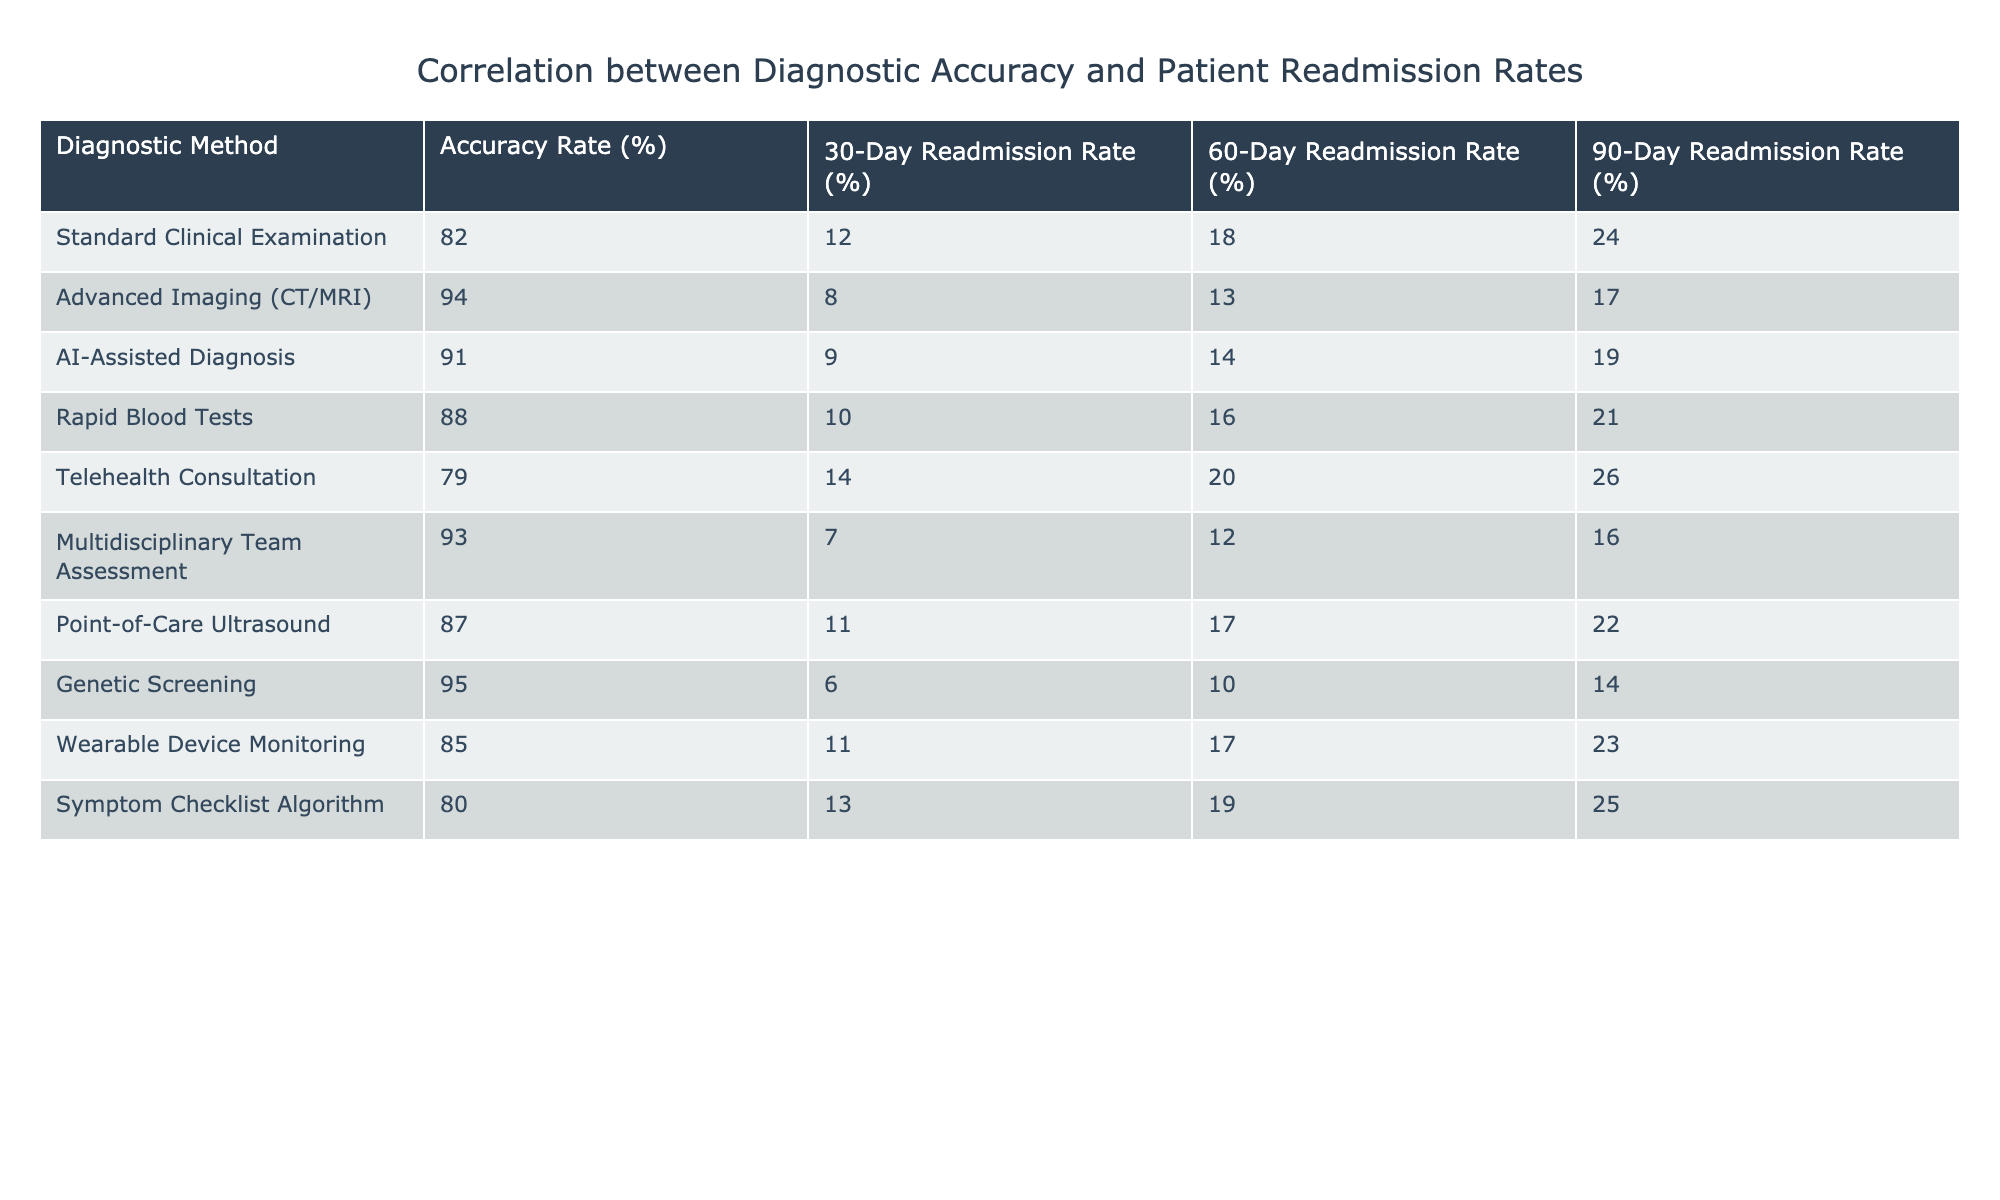What is the accuracy rate of Advanced Imaging? The accuracy rate for Advanced Imaging is listed in the table under the "Accuracy Rate (%)" column. It shows 94%.
Answer: 94% Which diagnostic method has the lowest 30-day readmission rate? By looking at the "30-Day Readmission Rate (%)" column, the lowest value is 6%, which corresponds to Genetic Screening.
Answer: Genetic Screening What is the difference in accuracy rate between Standard Clinical Examination and Telehealth Consultation? The accuracy rate for Standard Clinical Examination is 82% and for Telehealth Consultation, it is 79%. The difference is 82% - 79% = 3%.
Answer: 3% If a hospital uses the Multidisciplinary Team Assessment, what would be the expected 60-day readmission rate? The expected 60-day readmission rate for Multidisciplinary Team Assessment can be found in the "60-Day Readmission Rate (%)" column, which is 12%.
Answer: 12% True or False: AI-Assisted Diagnosis has a higher 90-day readmission rate than Rapid Blood Tests. From the table, the 90-day readmission rate for AI-Assisted Diagnosis is 19% and for Rapid Blood Tests, it is 21%. Therefore, AI-Assisted Diagnosis has a lower 90-day readmission rate.
Answer: False What is the average of the 30-day readmission rates for all diagnostic methods? First, sum all the values in the "30-Day Readmission Rate (%)" column: 12 + 8 + 9 + 10 + 14 + 7 + 11 + 6 + 11 + 13 = 91. There are 10 methods, so the average is 91 / 10 = 9.1%.
Answer: 9.1% Which diagnostic method offers both the highest accuracy rate and the lowest readmission rates across all time periods? By checking both accuracy and readmission rates, Genetic Screening has the highest accuracy at 95% and the lowest readmission rates at 6%, 10%, and 14% for the respective periods.
Answer: Genetic Screening What is the combined readmission rate for the 30-day and 60-day periods for Point-of-Care Ultrasound? The 30-day readmission rate for Point-of-Care Ultrasound is 11% and the 60-day rate is 17%. Summing these gives 11% + 17% = 28%.
Answer: 28% Which diagnostic method has the highest accuracy rate but does not have the lowest readmission rates? The highest accuracy rate is 95% for Genetic Screening; however, this method also has the lowest readmission rates, making Multidisciplinary Team Assessment, with an accuracy of 93%, the best match without the lowest readmission rates.
Answer: Multidisciplinary Team Assessment 